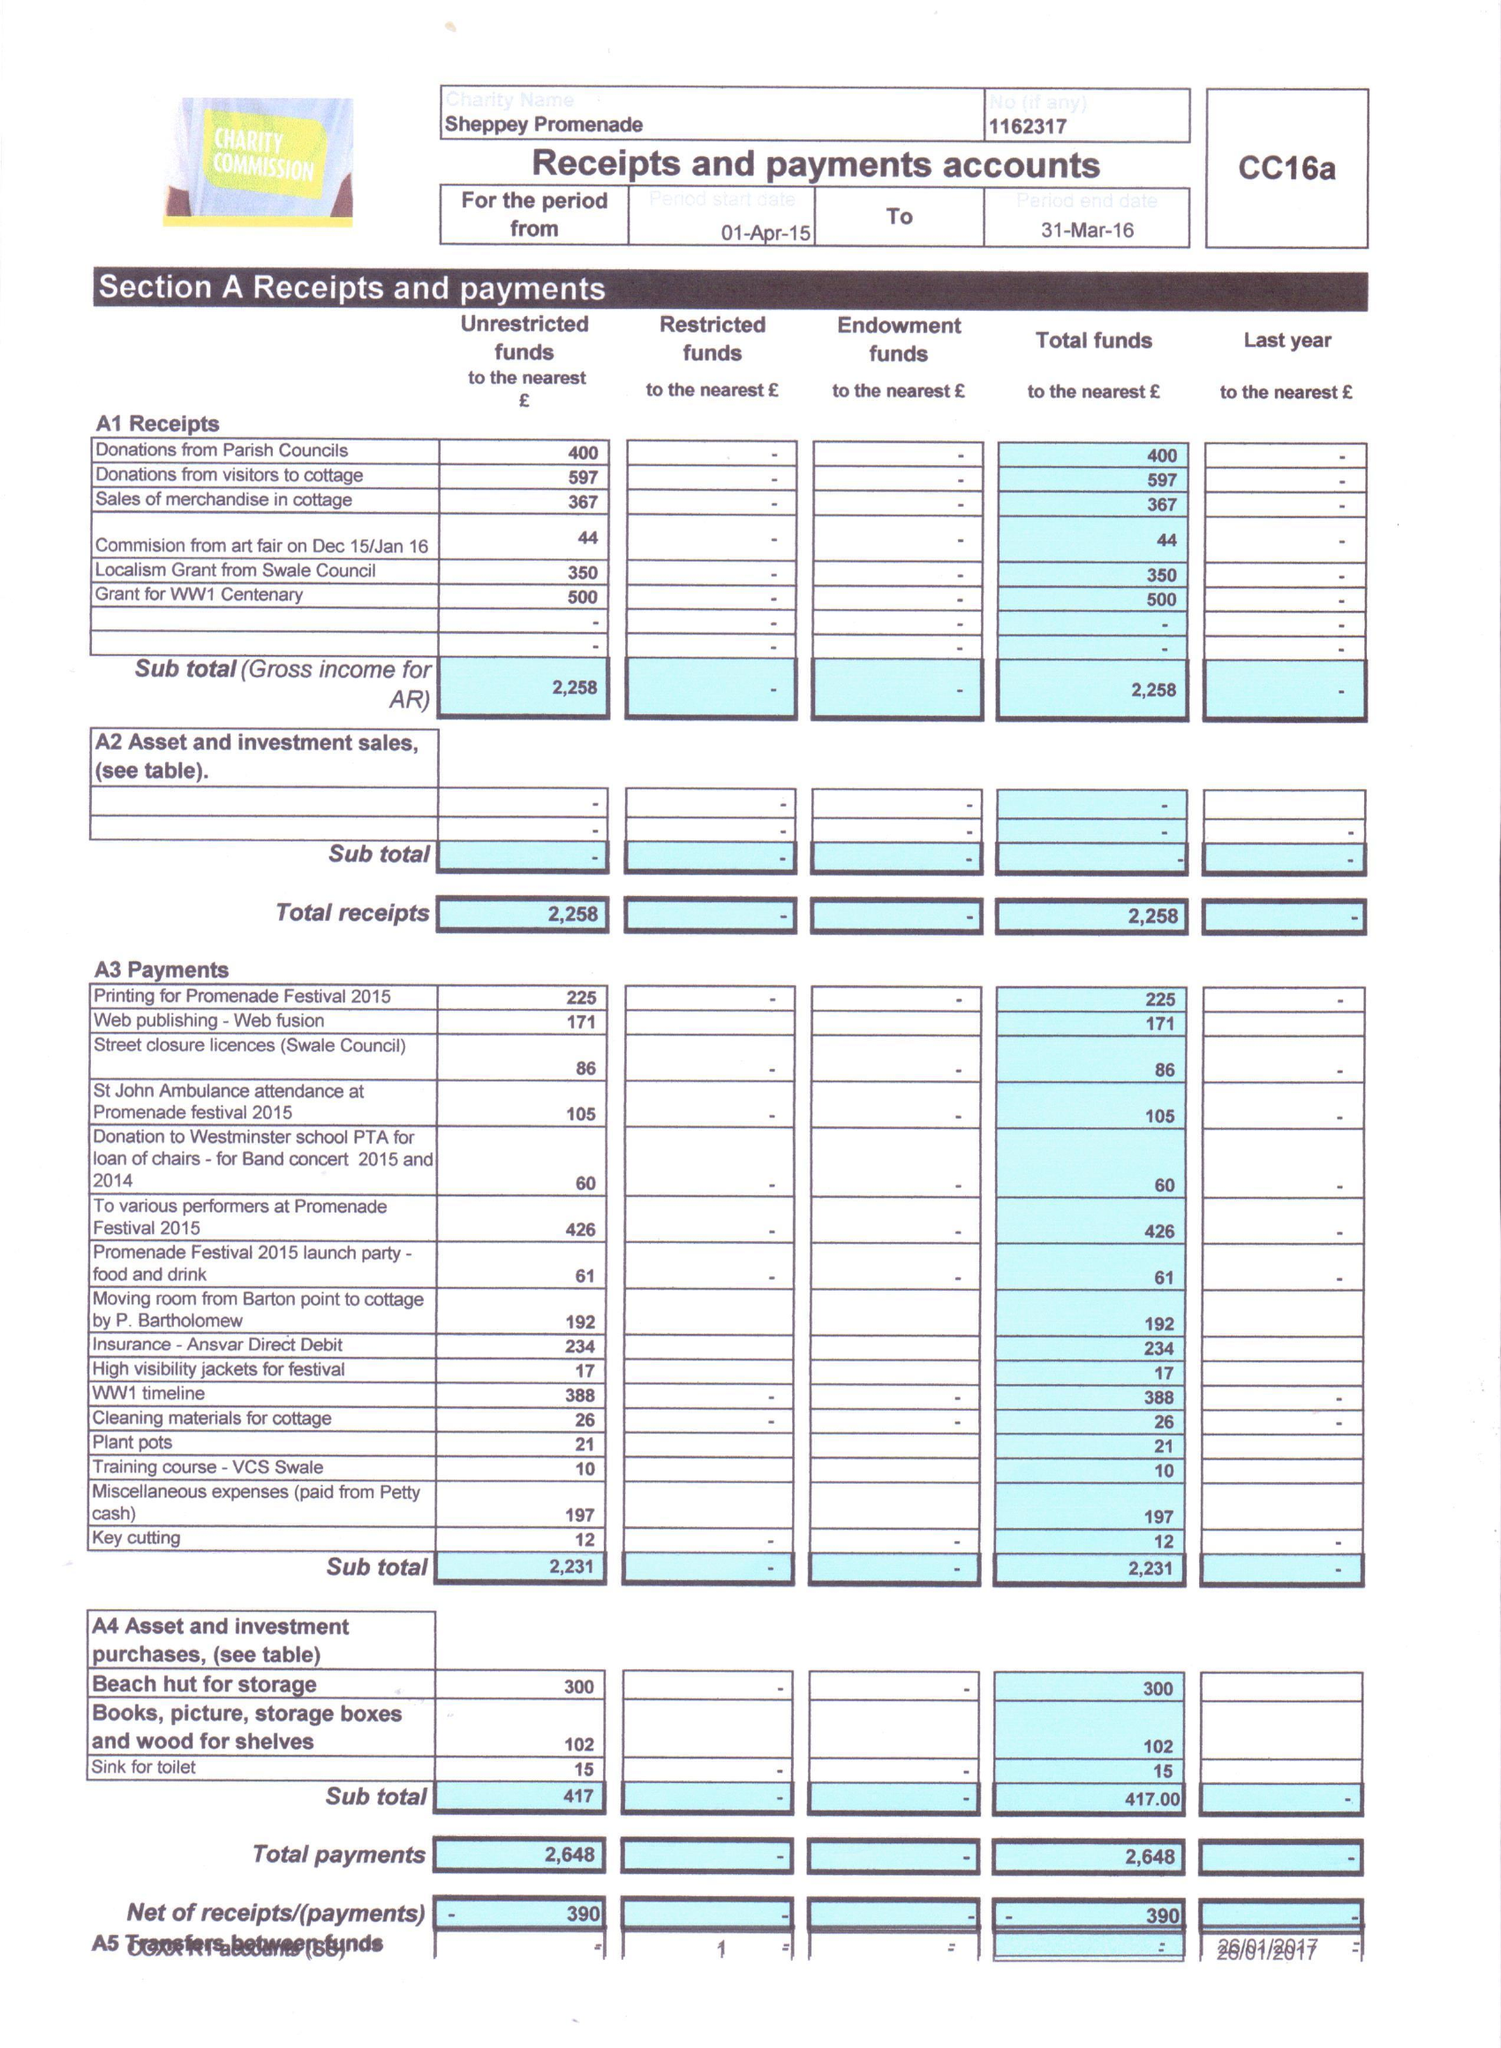What is the value for the address__post_town?
Answer the question using a single word or phrase. SHEERNESS 